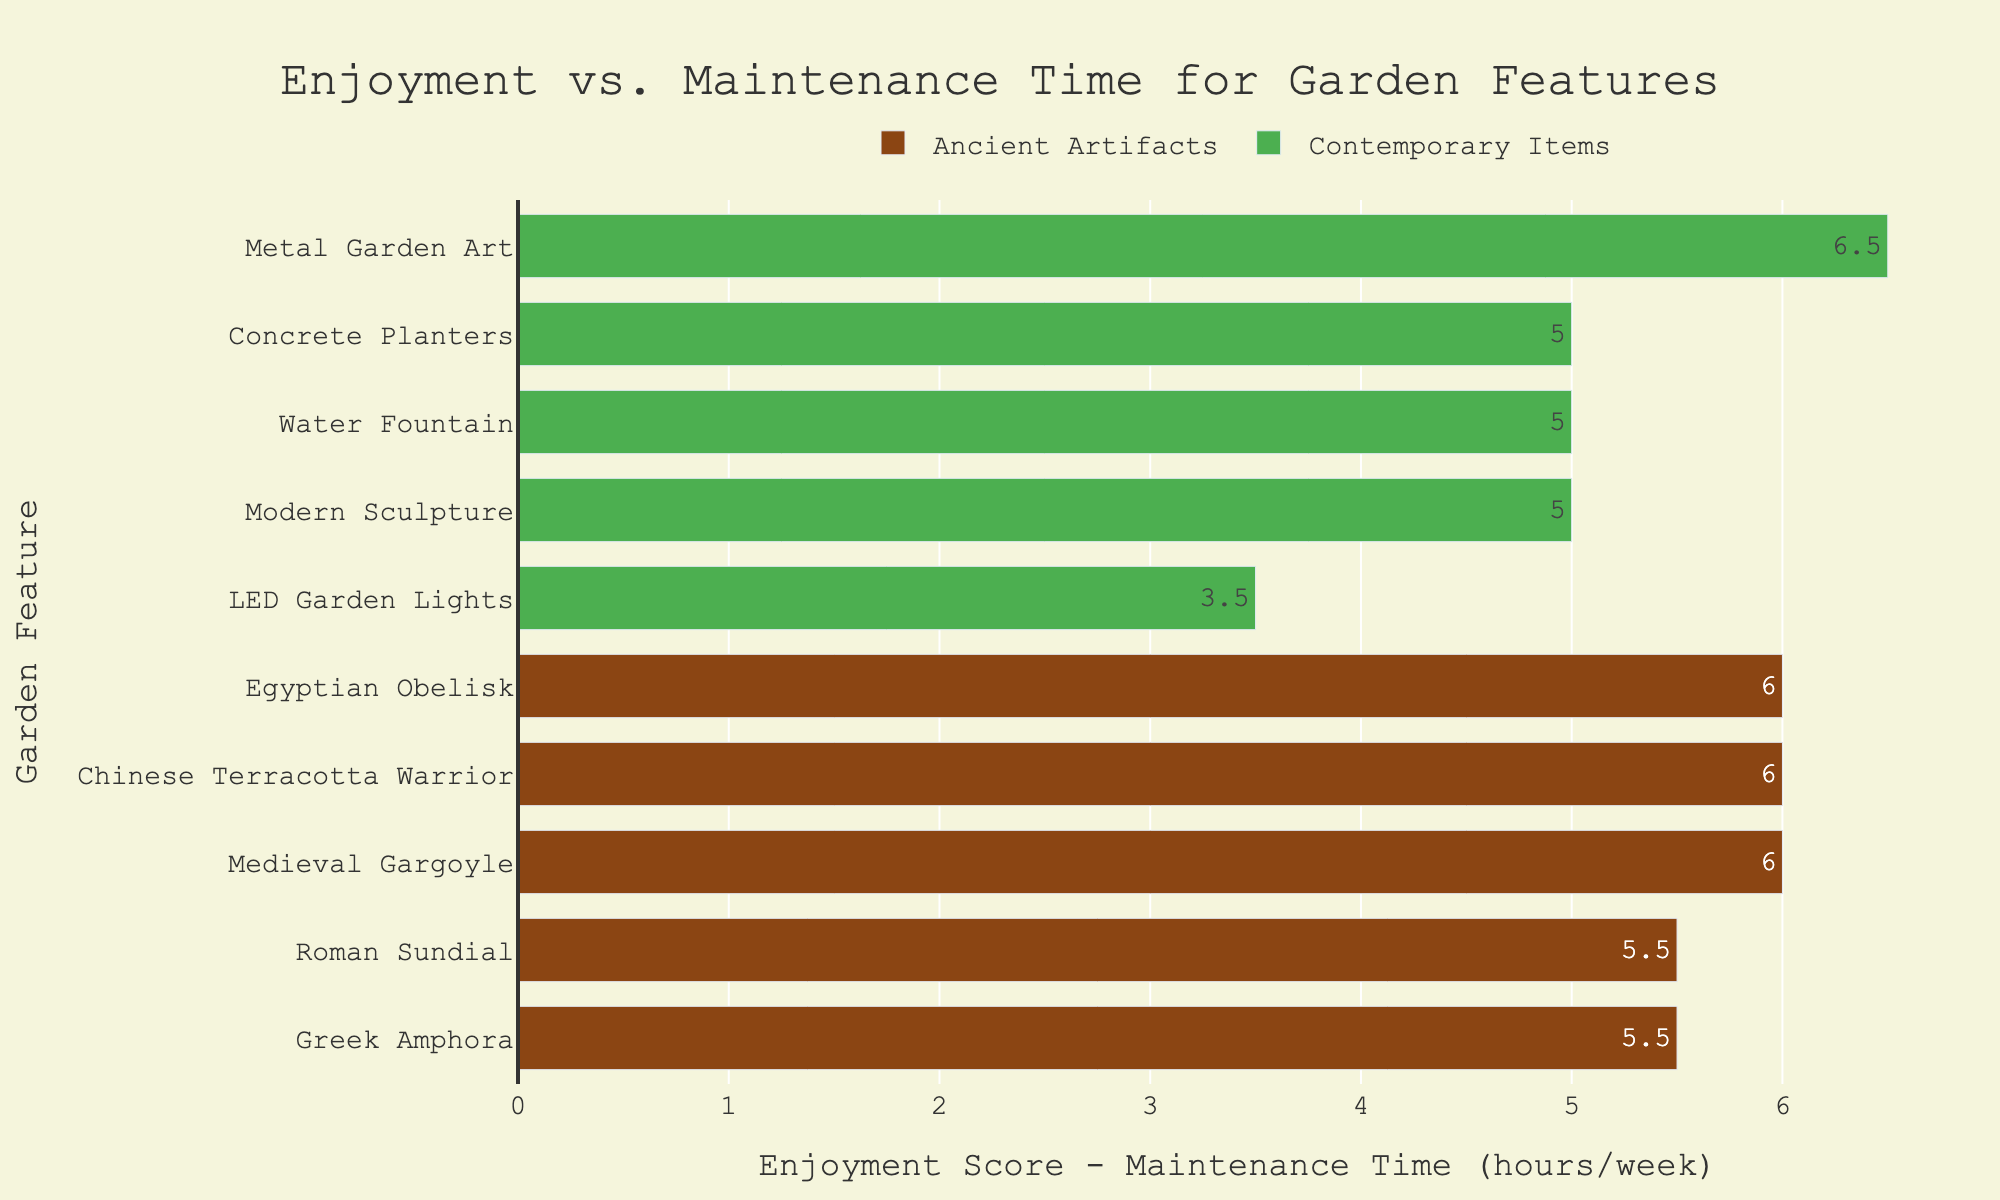Which ancient artifact has the highest enjoyment score? The enjoyment scores of ancient artifacts are plotted as bars. The Chinese Terracotta Warrior has the highest bar. Thus, the Chinese Terracotta Warrior has the highest enjoyment score.
Answer: Chinese Terracotta Warrior What is the difference between the enjoyment score and maintenance time for the Modern Sculpture? Locate the bar for Modern Sculpture under Contemporary Items and read the value of the difference. The Modern Sculpture's difference bar shows a value of 5.
Answer: 5 Which has a greater difference, the Greek Amphora or the LED Garden Lights? Compare the heights of the bars corresponding to Greek Amphora and LED Garden Lights. The Greek Amphora bar is higher showing a difference of 5.5, while LED Garden Lights shows a difference of 3.5.
Answer: Greek Amphora What is the average enjoyment score of the ancient artifacts? Sum the enjoyment scores of the ancient artifacts: (8 + 9 + 7 + 10 + 8) = 42. There are 5 items, so the average is 42/5.
Answer: 8.4 Which item has the smallest difference between enjoyment score and maintenance time? Look for the shortest bar in the entire chart. The LED Garden Lights have the smallest positive difference of 3.5.
Answer: LED Garden Lights Compare the average differences in enjoyment scores and maintenance times for Ancient Artifacts and Contemporary Items. Which category has a higher average difference? Calculate the average of the differences for each category. Ancient Artifacts: (5.5+6+5.5+6+6) / 5 = 5.8. Contemporary Items: (5+3.5+5+5+6.5) / 5 = 5.2. Compare the results: 5.8 for Ancient Artifacts and 5.2 for Contemporary Items.
Answer: Ancient Artifacts Is there any ancient artifact where the difference between enjoyment score and maintenance time is less than 5? If so, which one? Look for bars under Ancient Artifacts with differences less than 5. There are none.
Answer: No Which contemporary item has the highest maintenance time? Check the bars under Contemporary Items and read the maintenance time values. The Water Fountain has the highest maintenance time of 2 hours per week.
Answer: Water Fountain What is the total time spent on maintenance for contemporary items per week? Sum the maintenance times: (1 + 1.5 + 2 + 1 + 1.5). The result is: 7 hours/week.
Answer: 7 hours/week 